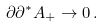<formula> <loc_0><loc_0><loc_500><loc_500>\partial \partial ^ { * } A _ { + } \rightarrow 0 \, .</formula> 